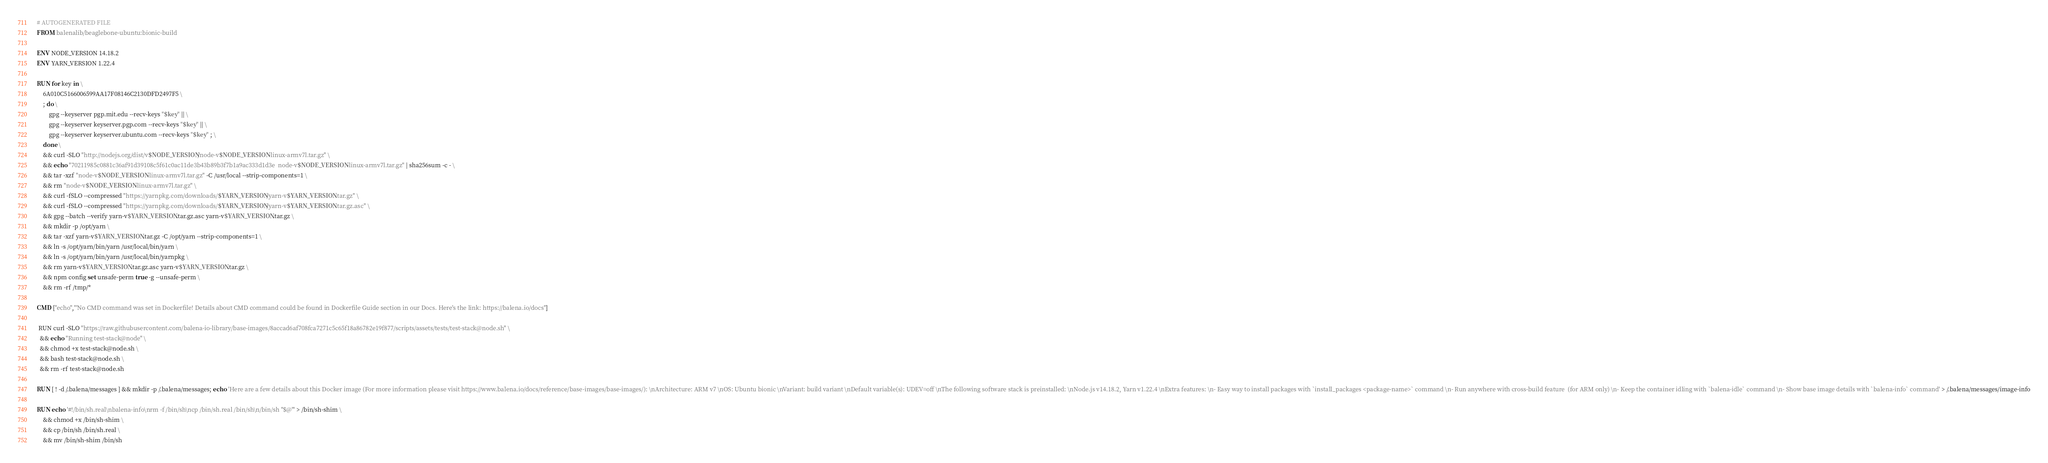Convert code to text. <code><loc_0><loc_0><loc_500><loc_500><_Dockerfile_># AUTOGENERATED FILE
FROM balenalib/beaglebone-ubuntu:bionic-build

ENV NODE_VERSION 14.18.2
ENV YARN_VERSION 1.22.4

RUN for key in \
	6A010C5166006599AA17F08146C2130DFD2497F5 \
	; do \
		gpg --keyserver pgp.mit.edu --recv-keys "$key" || \
		gpg --keyserver keyserver.pgp.com --recv-keys "$key" || \
		gpg --keyserver keyserver.ubuntu.com --recv-keys "$key" ; \
	done \
	&& curl -SLO "http://nodejs.org/dist/v$NODE_VERSION/node-v$NODE_VERSION-linux-armv7l.tar.gz" \
	&& echo "70211985c0881c36af91d39108c5f61c0ac11de3b43b89b3f7b1a9ac333d1d3e  node-v$NODE_VERSION-linux-armv7l.tar.gz" | sha256sum -c - \
	&& tar -xzf "node-v$NODE_VERSION-linux-armv7l.tar.gz" -C /usr/local --strip-components=1 \
	&& rm "node-v$NODE_VERSION-linux-armv7l.tar.gz" \
	&& curl -fSLO --compressed "https://yarnpkg.com/downloads/$YARN_VERSION/yarn-v$YARN_VERSION.tar.gz" \
	&& curl -fSLO --compressed "https://yarnpkg.com/downloads/$YARN_VERSION/yarn-v$YARN_VERSION.tar.gz.asc" \
	&& gpg --batch --verify yarn-v$YARN_VERSION.tar.gz.asc yarn-v$YARN_VERSION.tar.gz \
	&& mkdir -p /opt/yarn \
	&& tar -xzf yarn-v$YARN_VERSION.tar.gz -C /opt/yarn --strip-components=1 \
	&& ln -s /opt/yarn/bin/yarn /usr/local/bin/yarn \
	&& ln -s /opt/yarn/bin/yarn /usr/local/bin/yarnpkg \
	&& rm yarn-v$YARN_VERSION.tar.gz.asc yarn-v$YARN_VERSION.tar.gz \
	&& npm config set unsafe-perm true -g --unsafe-perm \
	&& rm -rf /tmp/*

CMD ["echo","'No CMD command was set in Dockerfile! Details about CMD command could be found in Dockerfile Guide section in our Docs. Here's the link: https://balena.io/docs"]

 RUN curl -SLO "https://raw.githubusercontent.com/balena-io-library/base-images/8accad6af708fca7271c5c65f18a86782e19f877/scripts/assets/tests/test-stack@node.sh" \
  && echo "Running test-stack@node" \
  && chmod +x test-stack@node.sh \
  && bash test-stack@node.sh \
  && rm -rf test-stack@node.sh 

RUN [ ! -d /.balena/messages ] && mkdir -p /.balena/messages; echo 'Here are a few details about this Docker image (For more information please visit https://www.balena.io/docs/reference/base-images/base-images/): \nArchitecture: ARM v7 \nOS: Ubuntu bionic \nVariant: build variant \nDefault variable(s): UDEV=off \nThe following software stack is preinstalled: \nNode.js v14.18.2, Yarn v1.22.4 \nExtra features: \n- Easy way to install packages with `install_packages <package-name>` command \n- Run anywhere with cross-build feature  (for ARM only) \n- Keep the container idling with `balena-idle` command \n- Show base image details with `balena-info` command' > /.balena/messages/image-info

RUN echo '#!/bin/sh.real\nbalena-info\nrm -f /bin/sh\ncp /bin/sh.real /bin/sh\n/bin/sh "$@"' > /bin/sh-shim \
	&& chmod +x /bin/sh-shim \
	&& cp /bin/sh /bin/sh.real \
	&& mv /bin/sh-shim /bin/sh</code> 